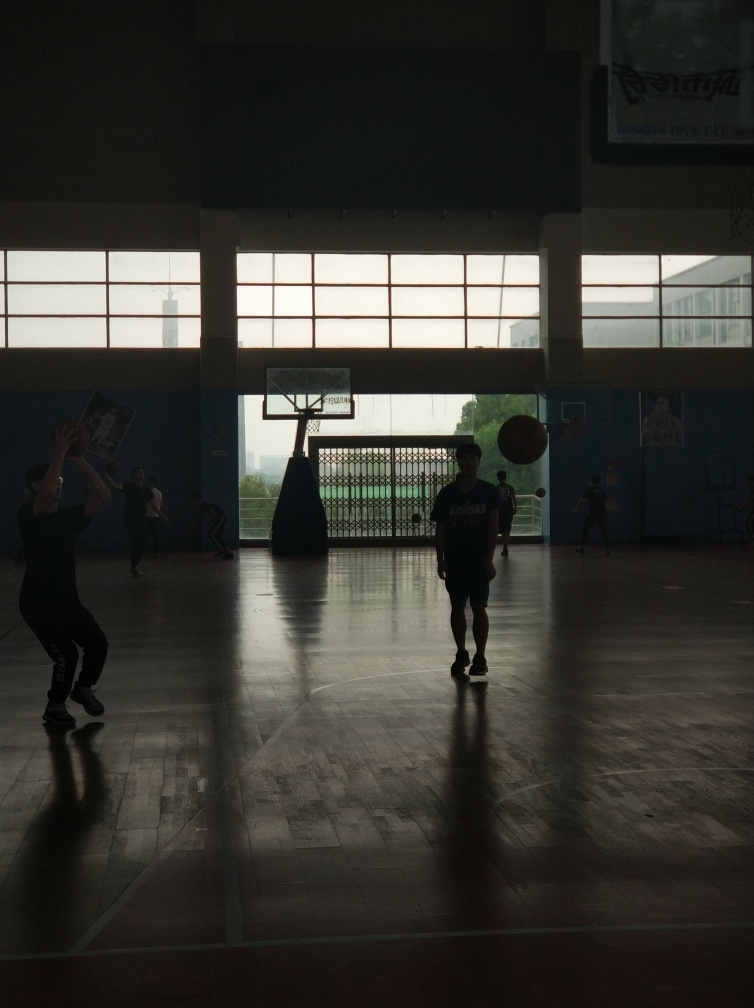How do the shadows contribute to the composition of this image? The shadows cast on the court add a dynamic element to the composition, highlighting the action and creating a sense of movement. They also emphasize the silhouette effect on the figures, delineating their shapes against the brightly lit background. Is there a particular mood or story you can infer from the scene? The interaction between the players and the contrasting light suggests a narrative of competition and camaraderie. The mood is intense yet playful, highlighting the joy and passion involved in the sport. 